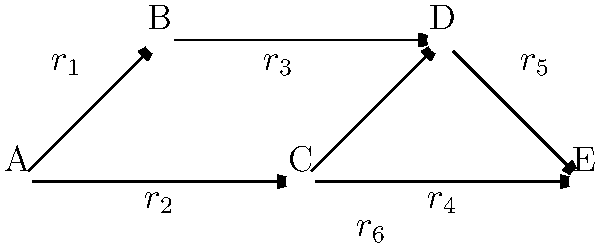In a social network represented by the diagram, propaganda messages spread from node to node at different rates $r_i$. The influence of a message at each node is given by $I(t) = 1 - e^{-kt}$, where $k$ is the sum of incoming rates and $t$ is time. To maximize the overall influence across the network, we need to optimize the allocation of a fixed total rate $R = r_1 + r_2 + r_3 + r_4 + r_5 + r_6$. Using calculus, determine the condition for optimal rate allocation to maximize influence at node E. To solve this optimization problem, we'll follow these steps:

1) The influence at node E depends on the rates coming from nodes C and D. So, we focus on $I_E(t) = 1 - e^{-kt}$, where $k = r_5 + r_6$.

2) To maximize influence, we want to maximize $I_E(t)$ or minimize $e^{-kt}$.

3) Given a fixed total rate $R$, we can express $r_6 = R - r_1 - r_2 - r_3 - r_4 - r_5$.

4) Now, $k = r_5 + (R - r_1 - r_2 - r_3 - r_4 - r_5) = R - r_1 - r_2 - r_3 - r_4$.

5) To find the optimal allocation, we need to maximize $k$ with respect to $r_1$, $r_2$, $r_3$, and $r_4$.

6) Taking partial derivatives:

   $\frac{\partial k}{\partial r_1} = -1$
   $\frac{\partial k}{\partial r_2} = -1$
   $\frac{\partial k}{\partial r_3} = -1$
   $\frac{\partial k}{\partial r_4} = -1$

7) For optimality, all these partial derivatives should be equal. This is already the case, so we don't need to equate them.

8) The condition for optimal allocation is that $r_1 = r_2 = r_3 = r_4$, and consequently, $r_5 + r_6 = R - 4r_1$.

This means that the rates leading to nodes A, B, C, and D should be equal, and the remaining rate should be distributed between the edges leading directly to E.
Answer: $r_1 = r_2 = r_3 = r_4$ and $r_5 + r_6 = R - 4r_1$ 